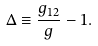<formula> <loc_0><loc_0><loc_500><loc_500>\Delta \equiv \frac { g _ { 1 2 } } { g } - 1 .</formula> 